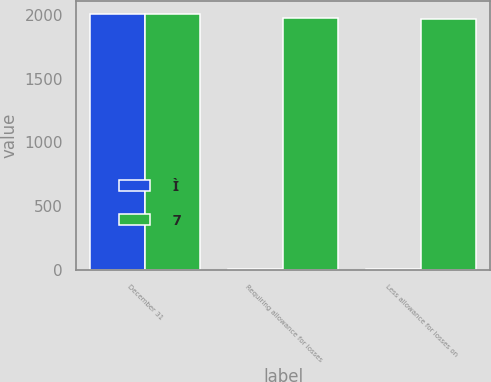Convert chart to OTSL. <chart><loc_0><loc_0><loc_500><loc_500><stacked_bar_chart><ecel><fcel>December 31<fcel>Requiring allowance for losses<fcel>Less allowance for losses on<nl><fcel>Ì<fcel>2005<fcel>10<fcel>10<nl><fcel>7<fcel>2004<fcel>1973<fcel>1966<nl></chart> 